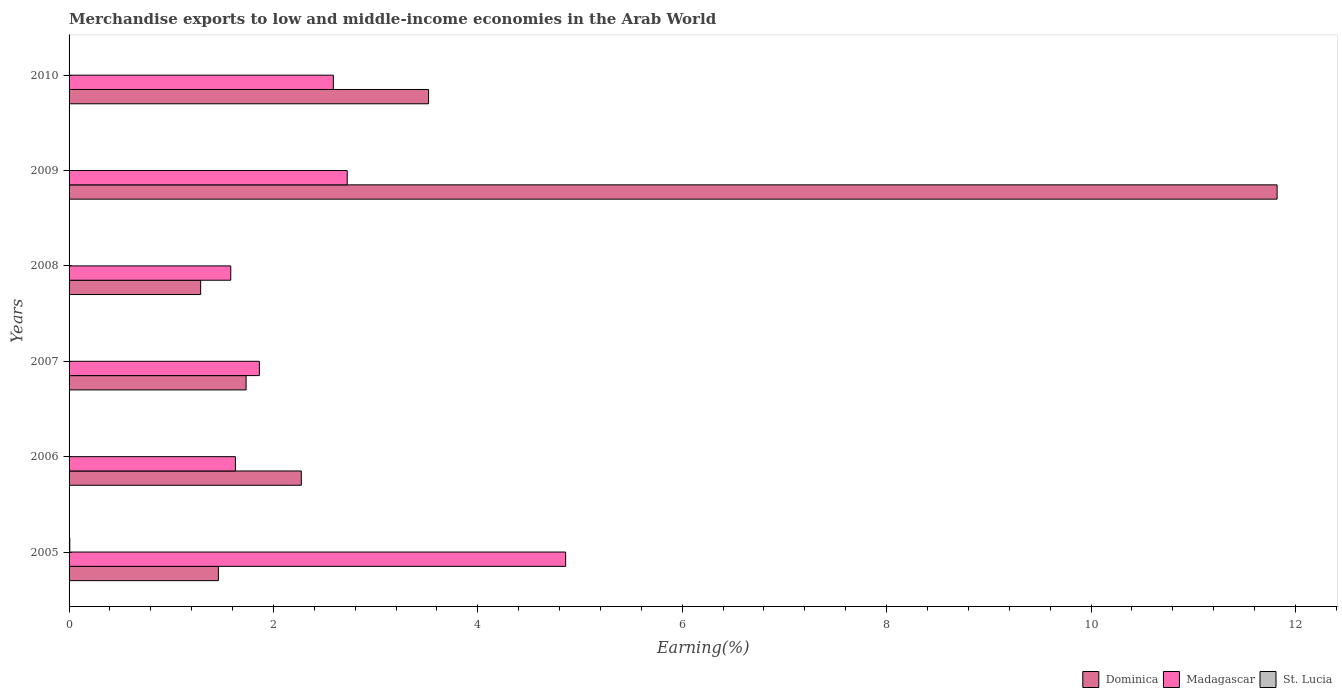How many different coloured bars are there?
Keep it short and to the point. 3. How many groups of bars are there?
Offer a terse response. 6. What is the label of the 3rd group of bars from the top?
Provide a succinct answer. 2008. In how many cases, is the number of bars for a given year not equal to the number of legend labels?
Offer a terse response. 0. What is the percentage of amount earned from merchandise exports in Dominica in 2009?
Ensure brevity in your answer.  11.82. Across all years, what is the maximum percentage of amount earned from merchandise exports in Dominica?
Provide a succinct answer. 11.82. Across all years, what is the minimum percentage of amount earned from merchandise exports in Madagascar?
Provide a short and direct response. 1.58. In which year was the percentage of amount earned from merchandise exports in Madagascar maximum?
Offer a terse response. 2005. What is the total percentage of amount earned from merchandise exports in Dominica in the graph?
Offer a very short reply. 22.09. What is the difference between the percentage of amount earned from merchandise exports in Madagascar in 2005 and that in 2009?
Offer a terse response. 2.14. What is the difference between the percentage of amount earned from merchandise exports in Dominica in 2005 and the percentage of amount earned from merchandise exports in St. Lucia in 2007?
Offer a very short reply. 1.46. What is the average percentage of amount earned from merchandise exports in St. Lucia per year?
Keep it short and to the point. 0. In the year 2007, what is the difference between the percentage of amount earned from merchandise exports in Madagascar and percentage of amount earned from merchandise exports in St. Lucia?
Offer a terse response. 1.86. What is the ratio of the percentage of amount earned from merchandise exports in Madagascar in 2007 to that in 2010?
Ensure brevity in your answer.  0.72. Is the difference between the percentage of amount earned from merchandise exports in Madagascar in 2006 and 2008 greater than the difference between the percentage of amount earned from merchandise exports in St. Lucia in 2006 and 2008?
Your answer should be very brief. Yes. What is the difference between the highest and the second highest percentage of amount earned from merchandise exports in Madagascar?
Your response must be concise. 2.14. What is the difference between the highest and the lowest percentage of amount earned from merchandise exports in Dominica?
Offer a very short reply. 10.53. In how many years, is the percentage of amount earned from merchandise exports in Dominica greater than the average percentage of amount earned from merchandise exports in Dominica taken over all years?
Your answer should be very brief. 1. What does the 3rd bar from the top in 2007 represents?
Your answer should be compact. Dominica. What does the 1st bar from the bottom in 2007 represents?
Make the answer very short. Dominica. Is it the case that in every year, the sum of the percentage of amount earned from merchandise exports in Madagascar and percentage of amount earned from merchandise exports in Dominica is greater than the percentage of amount earned from merchandise exports in St. Lucia?
Offer a terse response. Yes. Are all the bars in the graph horizontal?
Offer a very short reply. Yes. How many years are there in the graph?
Your answer should be very brief. 6. What is the difference between two consecutive major ticks on the X-axis?
Ensure brevity in your answer.  2. Are the values on the major ticks of X-axis written in scientific E-notation?
Provide a short and direct response. No. What is the title of the graph?
Keep it short and to the point. Merchandise exports to low and middle-income economies in the Arab World. What is the label or title of the X-axis?
Your answer should be compact. Earning(%). What is the label or title of the Y-axis?
Give a very brief answer. Years. What is the Earning(%) of Dominica in 2005?
Give a very brief answer. 1.46. What is the Earning(%) of Madagascar in 2005?
Provide a short and direct response. 4.86. What is the Earning(%) in St. Lucia in 2005?
Your answer should be very brief. 0.01. What is the Earning(%) in Dominica in 2006?
Give a very brief answer. 2.27. What is the Earning(%) of Madagascar in 2006?
Provide a short and direct response. 1.63. What is the Earning(%) of St. Lucia in 2006?
Make the answer very short. 0. What is the Earning(%) in Dominica in 2007?
Give a very brief answer. 1.73. What is the Earning(%) of Madagascar in 2007?
Provide a succinct answer. 1.86. What is the Earning(%) in St. Lucia in 2007?
Your answer should be very brief. 0. What is the Earning(%) in Dominica in 2008?
Keep it short and to the point. 1.29. What is the Earning(%) of Madagascar in 2008?
Your answer should be compact. 1.58. What is the Earning(%) of St. Lucia in 2008?
Keep it short and to the point. 0. What is the Earning(%) in Dominica in 2009?
Provide a succinct answer. 11.82. What is the Earning(%) in Madagascar in 2009?
Provide a succinct answer. 2.72. What is the Earning(%) of St. Lucia in 2009?
Your answer should be very brief. 0. What is the Earning(%) in Dominica in 2010?
Offer a terse response. 3.52. What is the Earning(%) in Madagascar in 2010?
Provide a succinct answer. 2.59. What is the Earning(%) of St. Lucia in 2010?
Your response must be concise. 0. Across all years, what is the maximum Earning(%) in Dominica?
Your answer should be compact. 11.82. Across all years, what is the maximum Earning(%) in Madagascar?
Your answer should be very brief. 4.86. Across all years, what is the maximum Earning(%) in St. Lucia?
Offer a terse response. 0.01. Across all years, what is the minimum Earning(%) of Dominica?
Offer a very short reply. 1.29. Across all years, what is the minimum Earning(%) in Madagascar?
Make the answer very short. 1.58. Across all years, what is the minimum Earning(%) of St. Lucia?
Make the answer very short. 0. What is the total Earning(%) in Dominica in the graph?
Provide a short and direct response. 22.09. What is the total Earning(%) of Madagascar in the graph?
Ensure brevity in your answer.  15.24. What is the total Earning(%) of St. Lucia in the graph?
Give a very brief answer. 0.01. What is the difference between the Earning(%) of Dominica in 2005 and that in 2006?
Your answer should be very brief. -0.81. What is the difference between the Earning(%) of Madagascar in 2005 and that in 2006?
Give a very brief answer. 3.23. What is the difference between the Earning(%) in St. Lucia in 2005 and that in 2006?
Keep it short and to the point. 0.01. What is the difference between the Earning(%) in Dominica in 2005 and that in 2007?
Ensure brevity in your answer.  -0.27. What is the difference between the Earning(%) in Madagascar in 2005 and that in 2007?
Provide a short and direct response. 3. What is the difference between the Earning(%) of St. Lucia in 2005 and that in 2007?
Provide a succinct answer. 0.01. What is the difference between the Earning(%) in Dominica in 2005 and that in 2008?
Provide a succinct answer. 0.17. What is the difference between the Earning(%) of Madagascar in 2005 and that in 2008?
Make the answer very short. 3.28. What is the difference between the Earning(%) in St. Lucia in 2005 and that in 2008?
Offer a very short reply. 0.01. What is the difference between the Earning(%) in Dominica in 2005 and that in 2009?
Provide a short and direct response. -10.36. What is the difference between the Earning(%) in Madagascar in 2005 and that in 2009?
Ensure brevity in your answer.  2.14. What is the difference between the Earning(%) of St. Lucia in 2005 and that in 2009?
Your response must be concise. 0.01. What is the difference between the Earning(%) of Dominica in 2005 and that in 2010?
Keep it short and to the point. -2.06. What is the difference between the Earning(%) of Madagascar in 2005 and that in 2010?
Provide a short and direct response. 2.27. What is the difference between the Earning(%) in St. Lucia in 2005 and that in 2010?
Keep it short and to the point. 0.01. What is the difference between the Earning(%) of Dominica in 2006 and that in 2007?
Keep it short and to the point. 0.54. What is the difference between the Earning(%) of Madagascar in 2006 and that in 2007?
Give a very brief answer. -0.23. What is the difference between the Earning(%) of St. Lucia in 2006 and that in 2007?
Provide a succinct answer. -0. What is the difference between the Earning(%) in Dominica in 2006 and that in 2008?
Provide a short and direct response. 0.99. What is the difference between the Earning(%) in Madagascar in 2006 and that in 2008?
Your response must be concise. 0.05. What is the difference between the Earning(%) in St. Lucia in 2006 and that in 2008?
Your answer should be compact. -0. What is the difference between the Earning(%) in Dominica in 2006 and that in 2009?
Make the answer very short. -9.55. What is the difference between the Earning(%) of Madagascar in 2006 and that in 2009?
Give a very brief answer. -1.09. What is the difference between the Earning(%) of St. Lucia in 2006 and that in 2009?
Provide a succinct answer. -0. What is the difference between the Earning(%) in Dominica in 2006 and that in 2010?
Keep it short and to the point. -1.25. What is the difference between the Earning(%) in Madagascar in 2006 and that in 2010?
Your answer should be very brief. -0.96. What is the difference between the Earning(%) in St. Lucia in 2006 and that in 2010?
Make the answer very short. -0. What is the difference between the Earning(%) in Dominica in 2007 and that in 2008?
Your answer should be very brief. 0.44. What is the difference between the Earning(%) of Madagascar in 2007 and that in 2008?
Your response must be concise. 0.28. What is the difference between the Earning(%) of St. Lucia in 2007 and that in 2008?
Your answer should be very brief. -0. What is the difference between the Earning(%) of Dominica in 2007 and that in 2009?
Offer a very short reply. -10.09. What is the difference between the Earning(%) of Madagascar in 2007 and that in 2009?
Your answer should be very brief. -0.86. What is the difference between the Earning(%) of Dominica in 2007 and that in 2010?
Your answer should be compact. -1.79. What is the difference between the Earning(%) of Madagascar in 2007 and that in 2010?
Keep it short and to the point. -0.72. What is the difference between the Earning(%) in St. Lucia in 2007 and that in 2010?
Offer a terse response. -0. What is the difference between the Earning(%) of Dominica in 2008 and that in 2009?
Your response must be concise. -10.53. What is the difference between the Earning(%) in Madagascar in 2008 and that in 2009?
Your answer should be very brief. -1.14. What is the difference between the Earning(%) of Dominica in 2008 and that in 2010?
Your answer should be compact. -2.23. What is the difference between the Earning(%) of Madagascar in 2008 and that in 2010?
Offer a very short reply. -1. What is the difference between the Earning(%) in St. Lucia in 2008 and that in 2010?
Provide a succinct answer. -0. What is the difference between the Earning(%) of Dominica in 2009 and that in 2010?
Make the answer very short. 8.3. What is the difference between the Earning(%) of Madagascar in 2009 and that in 2010?
Your answer should be compact. 0.14. What is the difference between the Earning(%) of St. Lucia in 2009 and that in 2010?
Make the answer very short. -0. What is the difference between the Earning(%) in Dominica in 2005 and the Earning(%) in Madagascar in 2006?
Keep it short and to the point. -0.17. What is the difference between the Earning(%) in Dominica in 2005 and the Earning(%) in St. Lucia in 2006?
Provide a short and direct response. 1.46. What is the difference between the Earning(%) in Madagascar in 2005 and the Earning(%) in St. Lucia in 2006?
Provide a succinct answer. 4.86. What is the difference between the Earning(%) in Dominica in 2005 and the Earning(%) in Madagascar in 2007?
Keep it short and to the point. -0.4. What is the difference between the Earning(%) of Dominica in 2005 and the Earning(%) of St. Lucia in 2007?
Ensure brevity in your answer.  1.46. What is the difference between the Earning(%) of Madagascar in 2005 and the Earning(%) of St. Lucia in 2007?
Keep it short and to the point. 4.86. What is the difference between the Earning(%) in Dominica in 2005 and the Earning(%) in Madagascar in 2008?
Ensure brevity in your answer.  -0.12. What is the difference between the Earning(%) in Dominica in 2005 and the Earning(%) in St. Lucia in 2008?
Make the answer very short. 1.46. What is the difference between the Earning(%) of Madagascar in 2005 and the Earning(%) of St. Lucia in 2008?
Your response must be concise. 4.86. What is the difference between the Earning(%) in Dominica in 2005 and the Earning(%) in Madagascar in 2009?
Your answer should be very brief. -1.26. What is the difference between the Earning(%) of Dominica in 2005 and the Earning(%) of St. Lucia in 2009?
Give a very brief answer. 1.46. What is the difference between the Earning(%) of Madagascar in 2005 and the Earning(%) of St. Lucia in 2009?
Your answer should be compact. 4.86. What is the difference between the Earning(%) in Dominica in 2005 and the Earning(%) in Madagascar in 2010?
Your response must be concise. -1.12. What is the difference between the Earning(%) of Dominica in 2005 and the Earning(%) of St. Lucia in 2010?
Provide a succinct answer. 1.46. What is the difference between the Earning(%) of Madagascar in 2005 and the Earning(%) of St. Lucia in 2010?
Ensure brevity in your answer.  4.86. What is the difference between the Earning(%) in Dominica in 2006 and the Earning(%) in Madagascar in 2007?
Give a very brief answer. 0.41. What is the difference between the Earning(%) of Dominica in 2006 and the Earning(%) of St. Lucia in 2007?
Offer a terse response. 2.27. What is the difference between the Earning(%) of Madagascar in 2006 and the Earning(%) of St. Lucia in 2007?
Your answer should be very brief. 1.63. What is the difference between the Earning(%) of Dominica in 2006 and the Earning(%) of Madagascar in 2008?
Offer a terse response. 0.69. What is the difference between the Earning(%) in Dominica in 2006 and the Earning(%) in St. Lucia in 2008?
Provide a short and direct response. 2.27. What is the difference between the Earning(%) of Madagascar in 2006 and the Earning(%) of St. Lucia in 2008?
Give a very brief answer. 1.63. What is the difference between the Earning(%) in Dominica in 2006 and the Earning(%) in Madagascar in 2009?
Your answer should be compact. -0.45. What is the difference between the Earning(%) in Dominica in 2006 and the Earning(%) in St. Lucia in 2009?
Your answer should be compact. 2.27. What is the difference between the Earning(%) in Madagascar in 2006 and the Earning(%) in St. Lucia in 2009?
Your answer should be compact. 1.63. What is the difference between the Earning(%) in Dominica in 2006 and the Earning(%) in Madagascar in 2010?
Your answer should be very brief. -0.31. What is the difference between the Earning(%) in Dominica in 2006 and the Earning(%) in St. Lucia in 2010?
Provide a short and direct response. 2.27. What is the difference between the Earning(%) of Madagascar in 2006 and the Earning(%) of St. Lucia in 2010?
Provide a short and direct response. 1.63. What is the difference between the Earning(%) of Dominica in 2007 and the Earning(%) of St. Lucia in 2008?
Keep it short and to the point. 1.73. What is the difference between the Earning(%) of Madagascar in 2007 and the Earning(%) of St. Lucia in 2008?
Offer a terse response. 1.86. What is the difference between the Earning(%) of Dominica in 2007 and the Earning(%) of Madagascar in 2009?
Provide a succinct answer. -0.99. What is the difference between the Earning(%) of Dominica in 2007 and the Earning(%) of St. Lucia in 2009?
Your answer should be compact. 1.73. What is the difference between the Earning(%) of Madagascar in 2007 and the Earning(%) of St. Lucia in 2009?
Offer a very short reply. 1.86. What is the difference between the Earning(%) of Dominica in 2007 and the Earning(%) of Madagascar in 2010?
Give a very brief answer. -0.85. What is the difference between the Earning(%) in Dominica in 2007 and the Earning(%) in St. Lucia in 2010?
Give a very brief answer. 1.73. What is the difference between the Earning(%) of Madagascar in 2007 and the Earning(%) of St. Lucia in 2010?
Provide a short and direct response. 1.86. What is the difference between the Earning(%) in Dominica in 2008 and the Earning(%) in Madagascar in 2009?
Give a very brief answer. -1.43. What is the difference between the Earning(%) of Dominica in 2008 and the Earning(%) of St. Lucia in 2009?
Your response must be concise. 1.29. What is the difference between the Earning(%) in Madagascar in 2008 and the Earning(%) in St. Lucia in 2009?
Your answer should be compact. 1.58. What is the difference between the Earning(%) in Dominica in 2008 and the Earning(%) in Madagascar in 2010?
Ensure brevity in your answer.  -1.3. What is the difference between the Earning(%) in Dominica in 2008 and the Earning(%) in St. Lucia in 2010?
Provide a short and direct response. 1.29. What is the difference between the Earning(%) in Madagascar in 2008 and the Earning(%) in St. Lucia in 2010?
Keep it short and to the point. 1.58. What is the difference between the Earning(%) of Dominica in 2009 and the Earning(%) of Madagascar in 2010?
Give a very brief answer. 9.24. What is the difference between the Earning(%) of Dominica in 2009 and the Earning(%) of St. Lucia in 2010?
Provide a succinct answer. 11.82. What is the difference between the Earning(%) of Madagascar in 2009 and the Earning(%) of St. Lucia in 2010?
Keep it short and to the point. 2.72. What is the average Earning(%) in Dominica per year?
Your answer should be compact. 3.68. What is the average Earning(%) in Madagascar per year?
Provide a short and direct response. 2.54. What is the average Earning(%) of St. Lucia per year?
Provide a short and direct response. 0. In the year 2005, what is the difference between the Earning(%) in Dominica and Earning(%) in Madagascar?
Your answer should be compact. -3.4. In the year 2005, what is the difference between the Earning(%) of Dominica and Earning(%) of St. Lucia?
Offer a terse response. 1.45. In the year 2005, what is the difference between the Earning(%) of Madagascar and Earning(%) of St. Lucia?
Keep it short and to the point. 4.85. In the year 2006, what is the difference between the Earning(%) in Dominica and Earning(%) in Madagascar?
Your answer should be compact. 0.64. In the year 2006, what is the difference between the Earning(%) of Dominica and Earning(%) of St. Lucia?
Give a very brief answer. 2.27. In the year 2006, what is the difference between the Earning(%) in Madagascar and Earning(%) in St. Lucia?
Your answer should be compact. 1.63. In the year 2007, what is the difference between the Earning(%) in Dominica and Earning(%) in Madagascar?
Offer a very short reply. -0.13. In the year 2007, what is the difference between the Earning(%) in Dominica and Earning(%) in St. Lucia?
Provide a short and direct response. 1.73. In the year 2007, what is the difference between the Earning(%) in Madagascar and Earning(%) in St. Lucia?
Provide a succinct answer. 1.86. In the year 2008, what is the difference between the Earning(%) in Dominica and Earning(%) in Madagascar?
Provide a succinct answer. -0.29. In the year 2008, what is the difference between the Earning(%) of Dominica and Earning(%) of St. Lucia?
Provide a succinct answer. 1.29. In the year 2008, what is the difference between the Earning(%) in Madagascar and Earning(%) in St. Lucia?
Keep it short and to the point. 1.58. In the year 2009, what is the difference between the Earning(%) of Dominica and Earning(%) of Madagascar?
Your response must be concise. 9.1. In the year 2009, what is the difference between the Earning(%) in Dominica and Earning(%) in St. Lucia?
Provide a short and direct response. 11.82. In the year 2009, what is the difference between the Earning(%) of Madagascar and Earning(%) of St. Lucia?
Give a very brief answer. 2.72. In the year 2010, what is the difference between the Earning(%) in Dominica and Earning(%) in Madagascar?
Provide a succinct answer. 0.93. In the year 2010, what is the difference between the Earning(%) in Dominica and Earning(%) in St. Lucia?
Offer a very short reply. 3.52. In the year 2010, what is the difference between the Earning(%) of Madagascar and Earning(%) of St. Lucia?
Keep it short and to the point. 2.58. What is the ratio of the Earning(%) in Dominica in 2005 to that in 2006?
Keep it short and to the point. 0.64. What is the ratio of the Earning(%) in Madagascar in 2005 to that in 2006?
Ensure brevity in your answer.  2.99. What is the ratio of the Earning(%) of St. Lucia in 2005 to that in 2006?
Provide a short and direct response. 44.02. What is the ratio of the Earning(%) of Dominica in 2005 to that in 2007?
Provide a succinct answer. 0.84. What is the ratio of the Earning(%) in Madagascar in 2005 to that in 2007?
Offer a very short reply. 2.61. What is the ratio of the Earning(%) of St. Lucia in 2005 to that in 2007?
Your response must be concise. 15.54. What is the ratio of the Earning(%) of Dominica in 2005 to that in 2008?
Provide a succinct answer. 1.14. What is the ratio of the Earning(%) of Madagascar in 2005 to that in 2008?
Keep it short and to the point. 3.07. What is the ratio of the Earning(%) in St. Lucia in 2005 to that in 2008?
Your answer should be compact. 11.65. What is the ratio of the Earning(%) of Dominica in 2005 to that in 2009?
Make the answer very short. 0.12. What is the ratio of the Earning(%) in Madagascar in 2005 to that in 2009?
Your answer should be compact. 1.79. What is the ratio of the Earning(%) of St. Lucia in 2005 to that in 2009?
Your answer should be compact. 18.04. What is the ratio of the Earning(%) in Dominica in 2005 to that in 2010?
Your answer should be compact. 0.42. What is the ratio of the Earning(%) of Madagascar in 2005 to that in 2010?
Provide a short and direct response. 1.88. What is the ratio of the Earning(%) in St. Lucia in 2005 to that in 2010?
Offer a very short reply. 7.22. What is the ratio of the Earning(%) in Dominica in 2006 to that in 2007?
Ensure brevity in your answer.  1.31. What is the ratio of the Earning(%) in Madagascar in 2006 to that in 2007?
Keep it short and to the point. 0.87. What is the ratio of the Earning(%) of St. Lucia in 2006 to that in 2007?
Give a very brief answer. 0.35. What is the ratio of the Earning(%) in Dominica in 2006 to that in 2008?
Your answer should be compact. 1.77. What is the ratio of the Earning(%) in Madagascar in 2006 to that in 2008?
Make the answer very short. 1.03. What is the ratio of the Earning(%) of St. Lucia in 2006 to that in 2008?
Ensure brevity in your answer.  0.26. What is the ratio of the Earning(%) in Dominica in 2006 to that in 2009?
Your response must be concise. 0.19. What is the ratio of the Earning(%) in Madagascar in 2006 to that in 2009?
Ensure brevity in your answer.  0.6. What is the ratio of the Earning(%) in St. Lucia in 2006 to that in 2009?
Offer a very short reply. 0.41. What is the ratio of the Earning(%) of Dominica in 2006 to that in 2010?
Give a very brief answer. 0.65. What is the ratio of the Earning(%) in Madagascar in 2006 to that in 2010?
Offer a terse response. 0.63. What is the ratio of the Earning(%) of St. Lucia in 2006 to that in 2010?
Provide a short and direct response. 0.16. What is the ratio of the Earning(%) in Dominica in 2007 to that in 2008?
Give a very brief answer. 1.35. What is the ratio of the Earning(%) in Madagascar in 2007 to that in 2008?
Your response must be concise. 1.18. What is the ratio of the Earning(%) of St. Lucia in 2007 to that in 2008?
Ensure brevity in your answer.  0.75. What is the ratio of the Earning(%) of Dominica in 2007 to that in 2009?
Provide a succinct answer. 0.15. What is the ratio of the Earning(%) of Madagascar in 2007 to that in 2009?
Your answer should be very brief. 0.68. What is the ratio of the Earning(%) of St. Lucia in 2007 to that in 2009?
Keep it short and to the point. 1.16. What is the ratio of the Earning(%) in Dominica in 2007 to that in 2010?
Your answer should be very brief. 0.49. What is the ratio of the Earning(%) of Madagascar in 2007 to that in 2010?
Your answer should be very brief. 0.72. What is the ratio of the Earning(%) of St. Lucia in 2007 to that in 2010?
Keep it short and to the point. 0.46. What is the ratio of the Earning(%) of Dominica in 2008 to that in 2009?
Provide a short and direct response. 0.11. What is the ratio of the Earning(%) in Madagascar in 2008 to that in 2009?
Provide a succinct answer. 0.58. What is the ratio of the Earning(%) in St. Lucia in 2008 to that in 2009?
Your answer should be compact. 1.55. What is the ratio of the Earning(%) of Dominica in 2008 to that in 2010?
Your answer should be compact. 0.37. What is the ratio of the Earning(%) of Madagascar in 2008 to that in 2010?
Give a very brief answer. 0.61. What is the ratio of the Earning(%) in St. Lucia in 2008 to that in 2010?
Offer a very short reply. 0.62. What is the ratio of the Earning(%) of Dominica in 2009 to that in 2010?
Ensure brevity in your answer.  3.36. What is the ratio of the Earning(%) in Madagascar in 2009 to that in 2010?
Your answer should be very brief. 1.05. What is the ratio of the Earning(%) in St. Lucia in 2009 to that in 2010?
Ensure brevity in your answer.  0.4. What is the difference between the highest and the second highest Earning(%) of Dominica?
Keep it short and to the point. 8.3. What is the difference between the highest and the second highest Earning(%) of Madagascar?
Offer a terse response. 2.14. What is the difference between the highest and the second highest Earning(%) in St. Lucia?
Provide a succinct answer. 0.01. What is the difference between the highest and the lowest Earning(%) of Dominica?
Provide a succinct answer. 10.53. What is the difference between the highest and the lowest Earning(%) of Madagascar?
Provide a succinct answer. 3.28. What is the difference between the highest and the lowest Earning(%) in St. Lucia?
Make the answer very short. 0.01. 